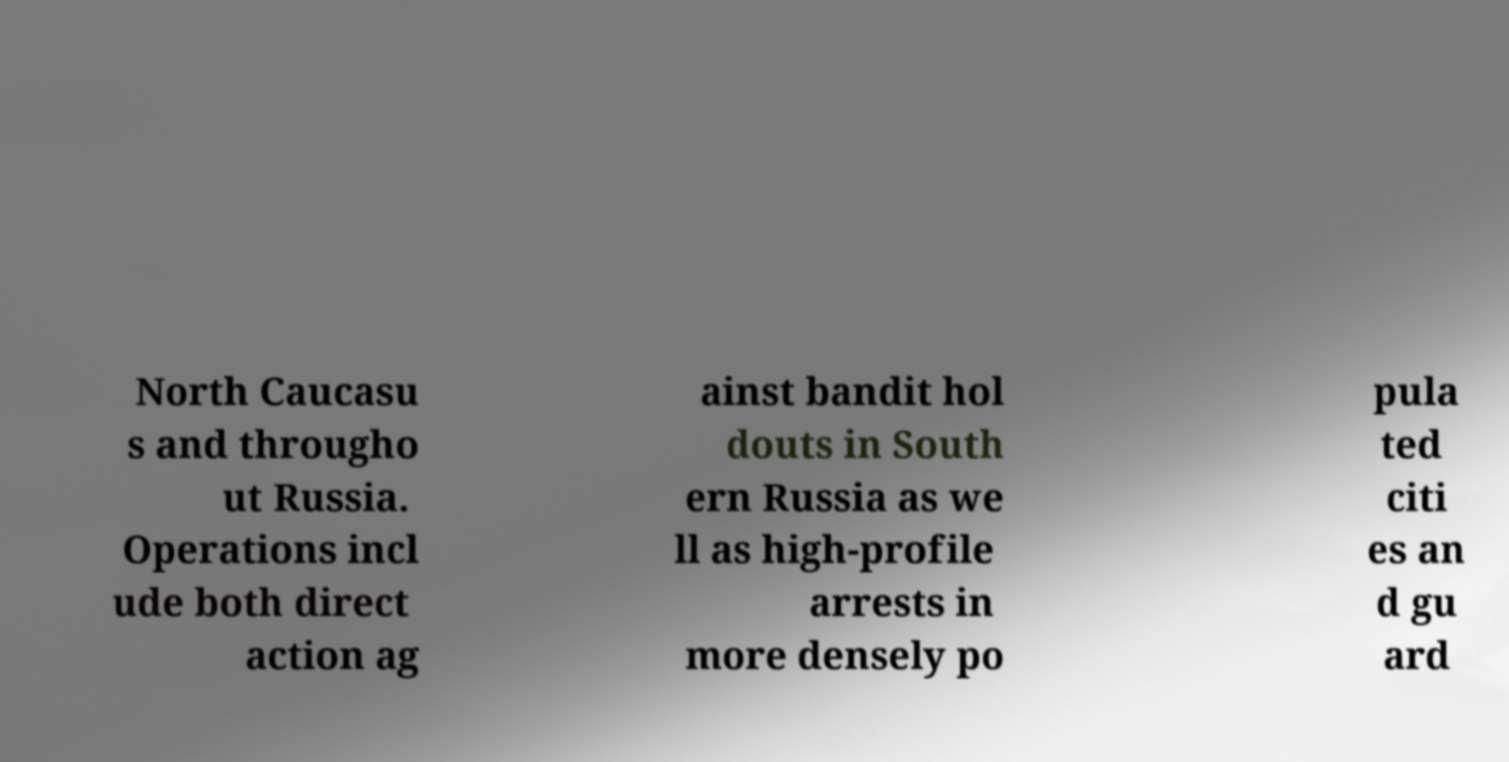Please identify and transcribe the text found in this image. North Caucasu s and througho ut Russia. Operations incl ude both direct action ag ainst bandit hol douts in South ern Russia as we ll as high-profile arrests in more densely po pula ted citi es an d gu ard 